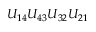Convert formula to latex. <formula><loc_0><loc_0><loc_500><loc_500>U _ { 1 4 } U _ { 4 3 } U _ { 3 2 } U _ { 2 1 }</formula> 